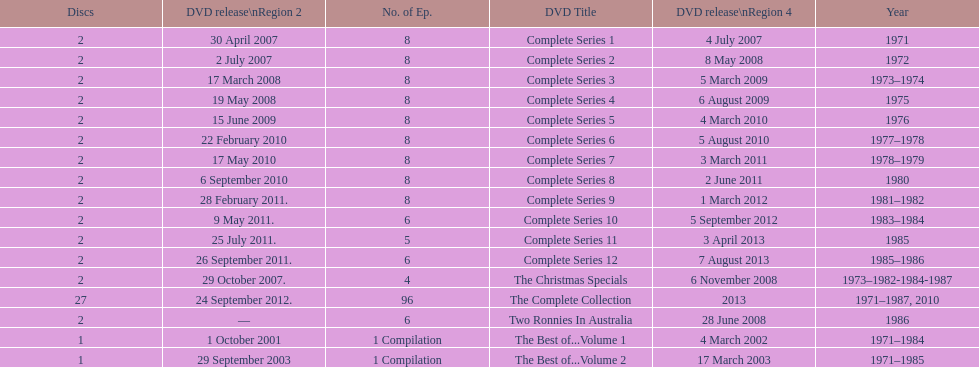The complete collection has 96 episodes, but the christmas specials only has how many episodes? 4. 